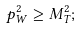<formula> <loc_0><loc_0><loc_500><loc_500>p _ { W } ^ { 2 } \geq M _ { T } ^ { 2 } ;</formula> 